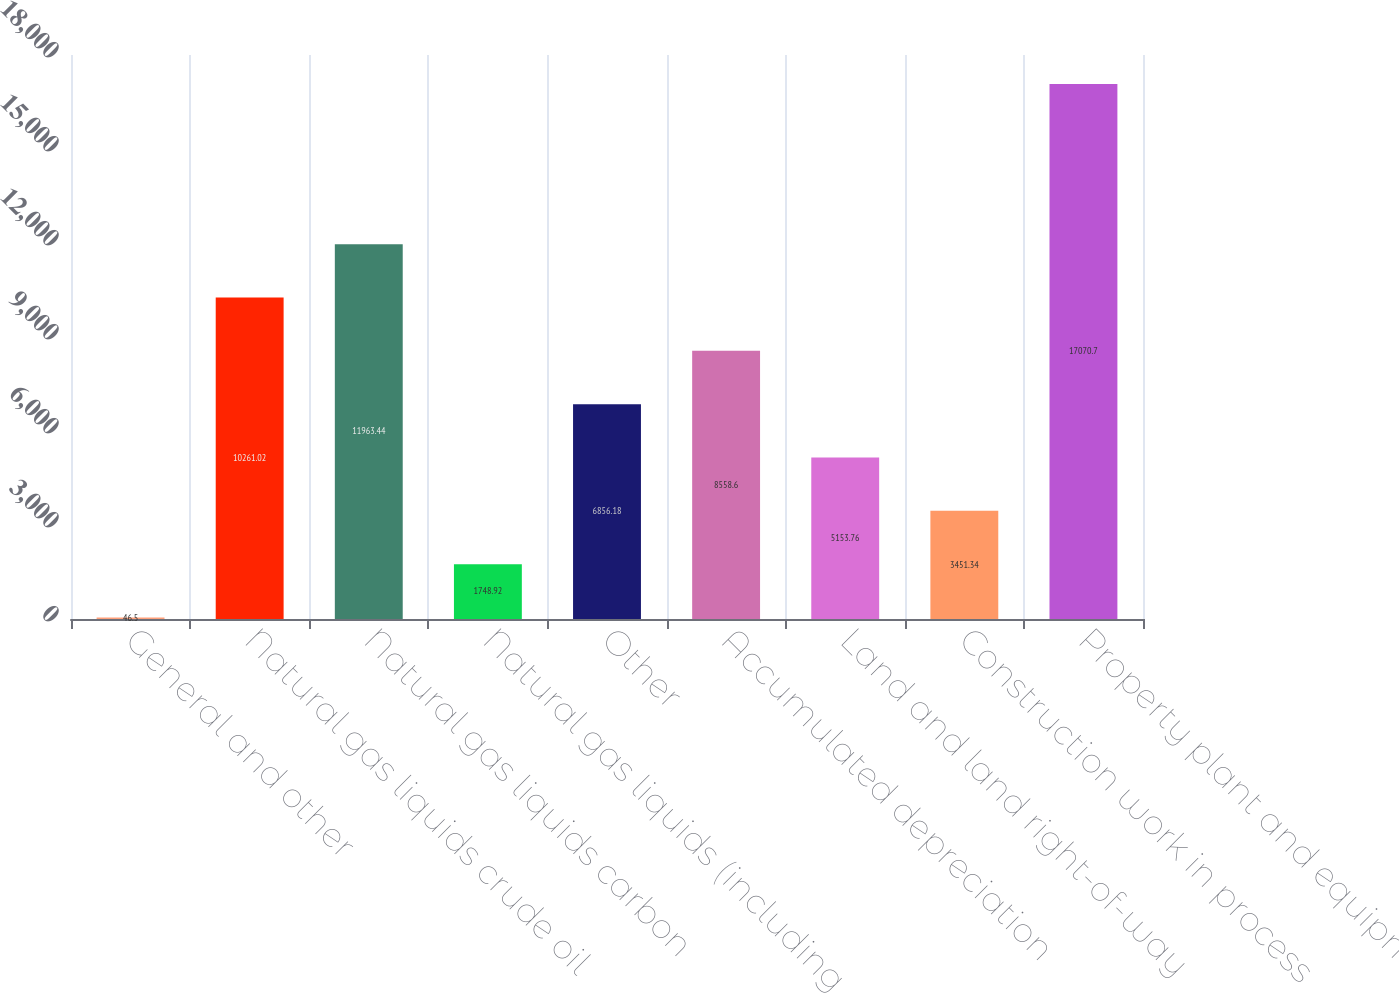Convert chart to OTSL. <chart><loc_0><loc_0><loc_500><loc_500><bar_chart><fcel>General and other<fcel>Natural gas liquids crude oil<fcel>Natural gas liquids carbon<fcel>Natural gas liquids (including<fcel>Other<fcel>Accumulated depreciation<fcel>Land and land right-of-way<fcel>Construction work in process<fcel>Property plant and equipment<nl><fcel>46.5<fcel>10261<fcel>11963.4<fcel>1748.92<fcel>6856.18<fcel>8558.6<fcel>5153.76<fcel>3451.34<fcel>17070.7<nl></chart> 